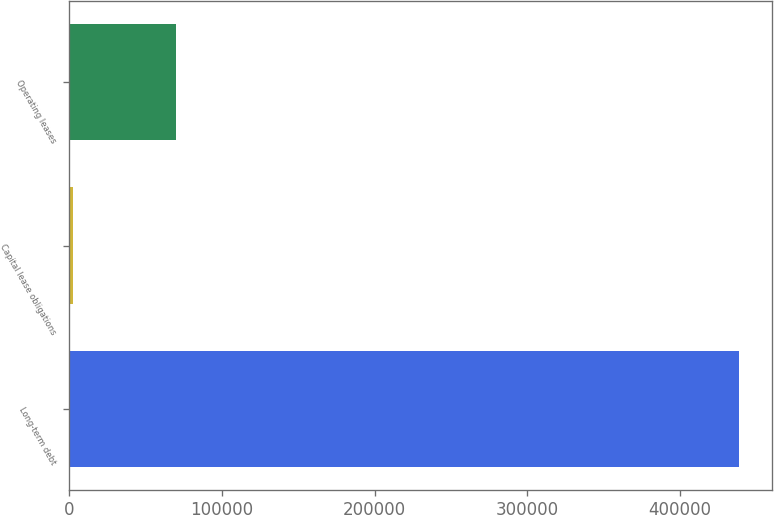Convert chart to OTSL. <chart><loc_0><loc_0><loc_500><loc_500><bar_chart><fcel>Long-term debt<fcel>Capital lease obligations<fcel>Operating leases<nl><fcel>438437<fcel>2380<fcel>69832<nl></chart> 